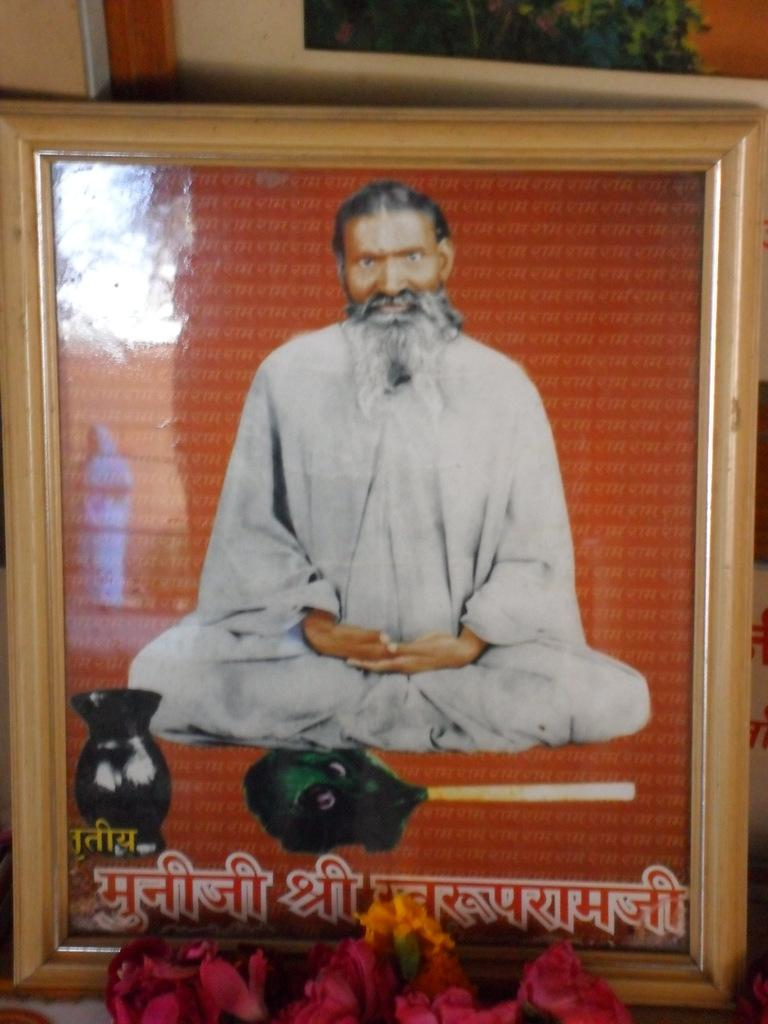What object in the image contains a picture or image? There is a photo frame in the image. What type of natural elements can be seen in the image? There are flowers in the image. What is the opinion of the flowers in the image? The flowers in the image do not have an opinion, as they are inanimate objects. What type of bead is used to decorate the photo frame in the image? There is no mention of beads in the image or the provided facts, so we cannot determine if any beads are present. 